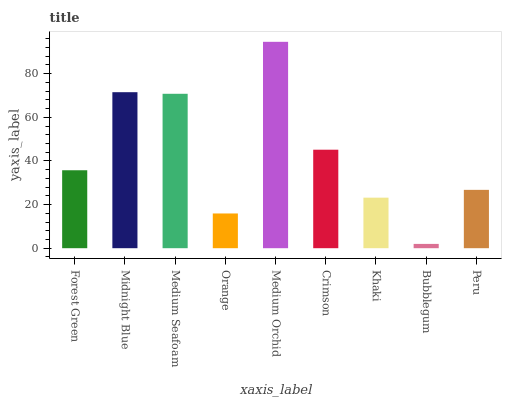Is Bubblegum the minimum?
Answer yes or no. Yes. Is Medium Orchid the maximum?
Answer yes or no. Yes. Is Midnight Blue the minimum?
Answer yes or no. No. Is Midnight Blue the maximum?
Answer yes or no. No. Is Midnight Blue greater than Forest Green?
Answer yes or no. Yes. Is Forest Green less than Midnight Blue?
Answer yes or no. Yes. Is Forest Green greater than Midnight Blue?
Answer yes or no. No. Is Midnight Blue less than Forest Green?
Answer yes or no. No. Is Forest Green the high median?
Answer yes or no. Yes. Is Forest Green the low median?
Answer yes or no. Yes. Is Orange the high median?
Answer yes or no. No. Is Orange the low median?
Answer yes or no. No. 